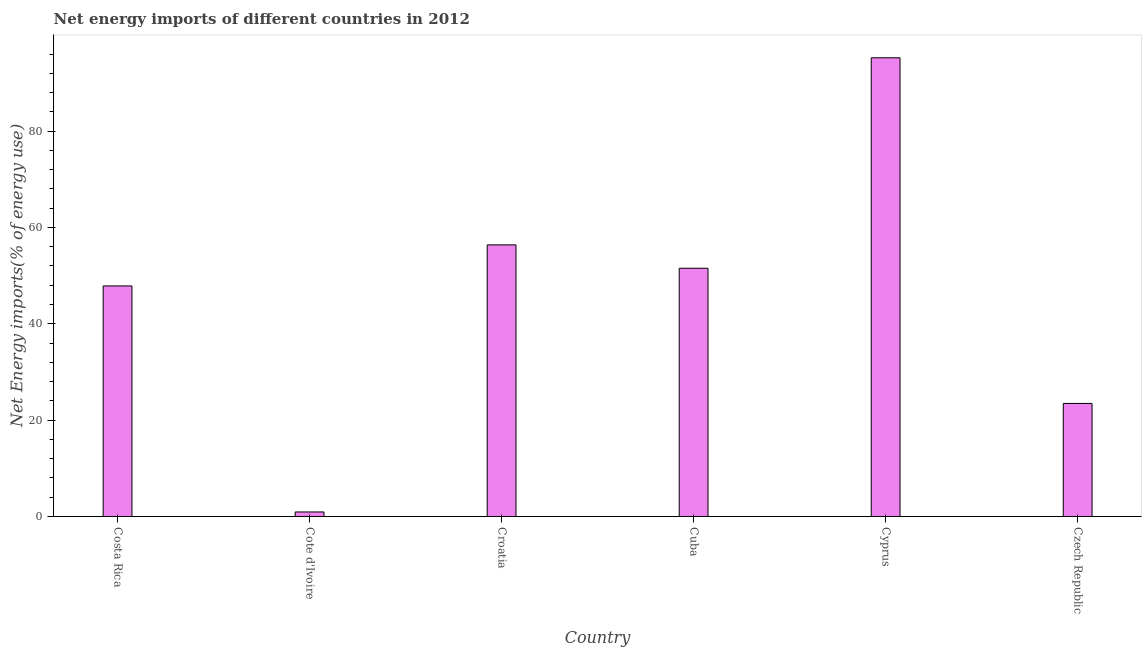What is the title of the graph?
Give a very brief answer. Net energy imports of different countries in 2012. What is the label or title of the Y-axis?
Give a very brief answer. Net Energy imports(% of energy use). What is the energy imports in Czech Republic?
Your response must be concise. 23.47. Across all countries, what is the maximum energy imports?
Your response must be concise. 95.21. Across all countries, what is the minimum energy imports?
Your answer should be compact. 0.94. In which country was the energy imports maximum?
Offer a terse response. Cyprus. In which country was the energy imports minimum?
Keep it short and to the point. Cote d'Ivoire. What is the sum of the energy imports?
Offer a very short reply. 275.39. What is the difference between the energy imports in Croatia and Czech Republic?
Your response must be concise. 32.92. What is the average energy imports per country?
Your response must be concise. 45.9. What is the median energy imports?
Ensure brevity in your answer.  49.69. What is the ratio of the energy imports in Croatia to that in Czech Republic?
Offer a very short reply. 2.4. Is the energy imports in Cote d'Ivoire less than that in Croatia?
Give a very brief answer. Yes. What is the difference between the highest and the second highest energy imports?
Make the answer very short. 38.83. Is the sum of the energy imports in Cuba and Czech Republic greater than the maximum energy imports across all countries?
Offer a terse response. No. What is the difference between the highest and the lowest energy imports?
Offer a very short reply. 94.27. In how many countries, is the energy imports greater than the average energy imports taken over all countries?
Provide a succinct answer. 4. How many bars are there?
Provide a short and direct response. 6. What is the Net Energy imports(% of energy use) in Costa Rica?
Your response must be concise. 47.86. What is the Net Energy imports(% of energy use) of Cote d'Ivoire?
Provide a succinct answer. 0.94. What is the Net Energy imports(% of energy use) of Croatia?
Your answer should be compact. 56.38. What is the Net Energy imports(% of energy use) of Cuba?
Your answer should be compact. 51.53. What is the Net Energy imports(% of energy use) in Cyprus?
Offer a very short reply. 95.21. What is the Net Energy imports(% of energy use) in Czech Republic?
Provide a succinct answer. 23.47. What is the difference between the Net Energy imports(% of energy use) in Costa Rica and Cote d'Ivoire?
Your response must be concise. 46.92. What is the difference between the Net Energy imports(% of energy use) in Costa Rica and Croatia?
Offer a very short reply. -8.52. What is the difference between the Net Energy imports(% of energy use) in Costa Rica and Cuba?
Ensure brevity in your answer.  -3.67. What is the difference between the Net Energy imports(% of energy use) in Costa Rica and Cyprus?
Ensure brevity in your answer.  -47.35. What is the difference between the Net Energy imports(% of energy use) in Costa Rica and Czech Republic?
Offer a very short reply. 24.39. What is the difference between the Net Energy imports(% of energy use) in Cote d'Ivoire and Croatia?
Your answer should be compact. -55.44. What is the difference between the Net Energy imports(% of energy use) in Cote d'Ivoire and Cuba?
Offer a terse response. -50.59. What is the difference between the Net Energy imports(% of energy use) in Cote d'Ivoire and Cyprus?
Keep it short and to the point. -94.27. What is the difference between the Net Energy imports(% of energy use) in Cote d'Ivoire and Czech Republic?
Provide a short and direct response. -22.53. What is the difference between the Net Energy imports(% of energy use) in Croatia and Cuba?
Your answer should be very brief. 4.85. What is the difference between the Net Energy imports(% of energy use) in Croatia and Cyprus?
Give a very brief answer. -38.83. What is the difference between the Net Energy imports(% of energy use) in Croatia and Czech Republic?
Provide a succinct answer. 32.92. What is the difference between the Net Energy imports(% of energy use) in Cuba and Cyprus?
Your response must be concise. -43.69. What is the difference between the Net Energy imports(% of energy use) in Cuba and Czech Republic?
Your response must be concise. 28.06. What is the difference between the Net Energy imports(% of energy use) in Cyprus and Czech Republic?
Provide a succinct answer. 71.75. What is the ratio of the Net Energy imports(% of energy use) in Costa Rica to that in Cote d'Ivoire?
Make the answer very short. 50.96. What is the ratio of the Net Energy imports(% of energy use) in Costa Rica to that in Croatia?
Your response must be concise. 0.85. What is the ratio of the Net Energy imports(% of energy use) in Costa Rica to that in Cuba?
Provide a short and direct response. 0.93. What is the ratio of the Net Energy imports(% of energy use) in Costa Rica to that in Cyprus?
Provide a succinct answer. 0.5. What is the ratio of the Net Energy imports(% of energy use) in Costa Rica to that in Czech Republic?
Provide a short and direct response. 2.04. What is the ratio of the Net Energy imports(% of energy use) in Cote d'Ivoire to that in Croatia?
Provide a short and direct response. 0.02. What is the ratio of the Net Energy imports(% of energy use) in Cote d'Ivoire to that in Cuba?
Offer a very short reply. 0.02. What is the ratio of the Net Energy imports(% of energy use) in Cote d'Ivoire to that in Czech Republic?
Provide a succinct answer. 0.04. What is the ratio of the Net Energy imports(% of energy use) in Croatia to that in Cuba?
Your answer should be compact. 1.09. What is the ratio of the Net Energy imports(% of energy use) in Croatia to that in Cyprus?
Your answer should be very brief. 0.59. What is the ratio of the Net Energy imports(% of energy use) in Croatia to that in Czech Republic?
Your response must be concise. 2.4. What is the ratio of the Net Energy imports(% of energy use) in Cuba to that in Cyprus?
Your response must be concise. 0.54. What is the ratio of the Net Energy imports(% of energy use) in Cuba to that in Czech Republic?
Offer a very short reply. 2.2. What is the ratio of the Net Energy imports(% of energy use) in Cyprus to that in Czech Republic?
Offer a very short reply. 4.06. 